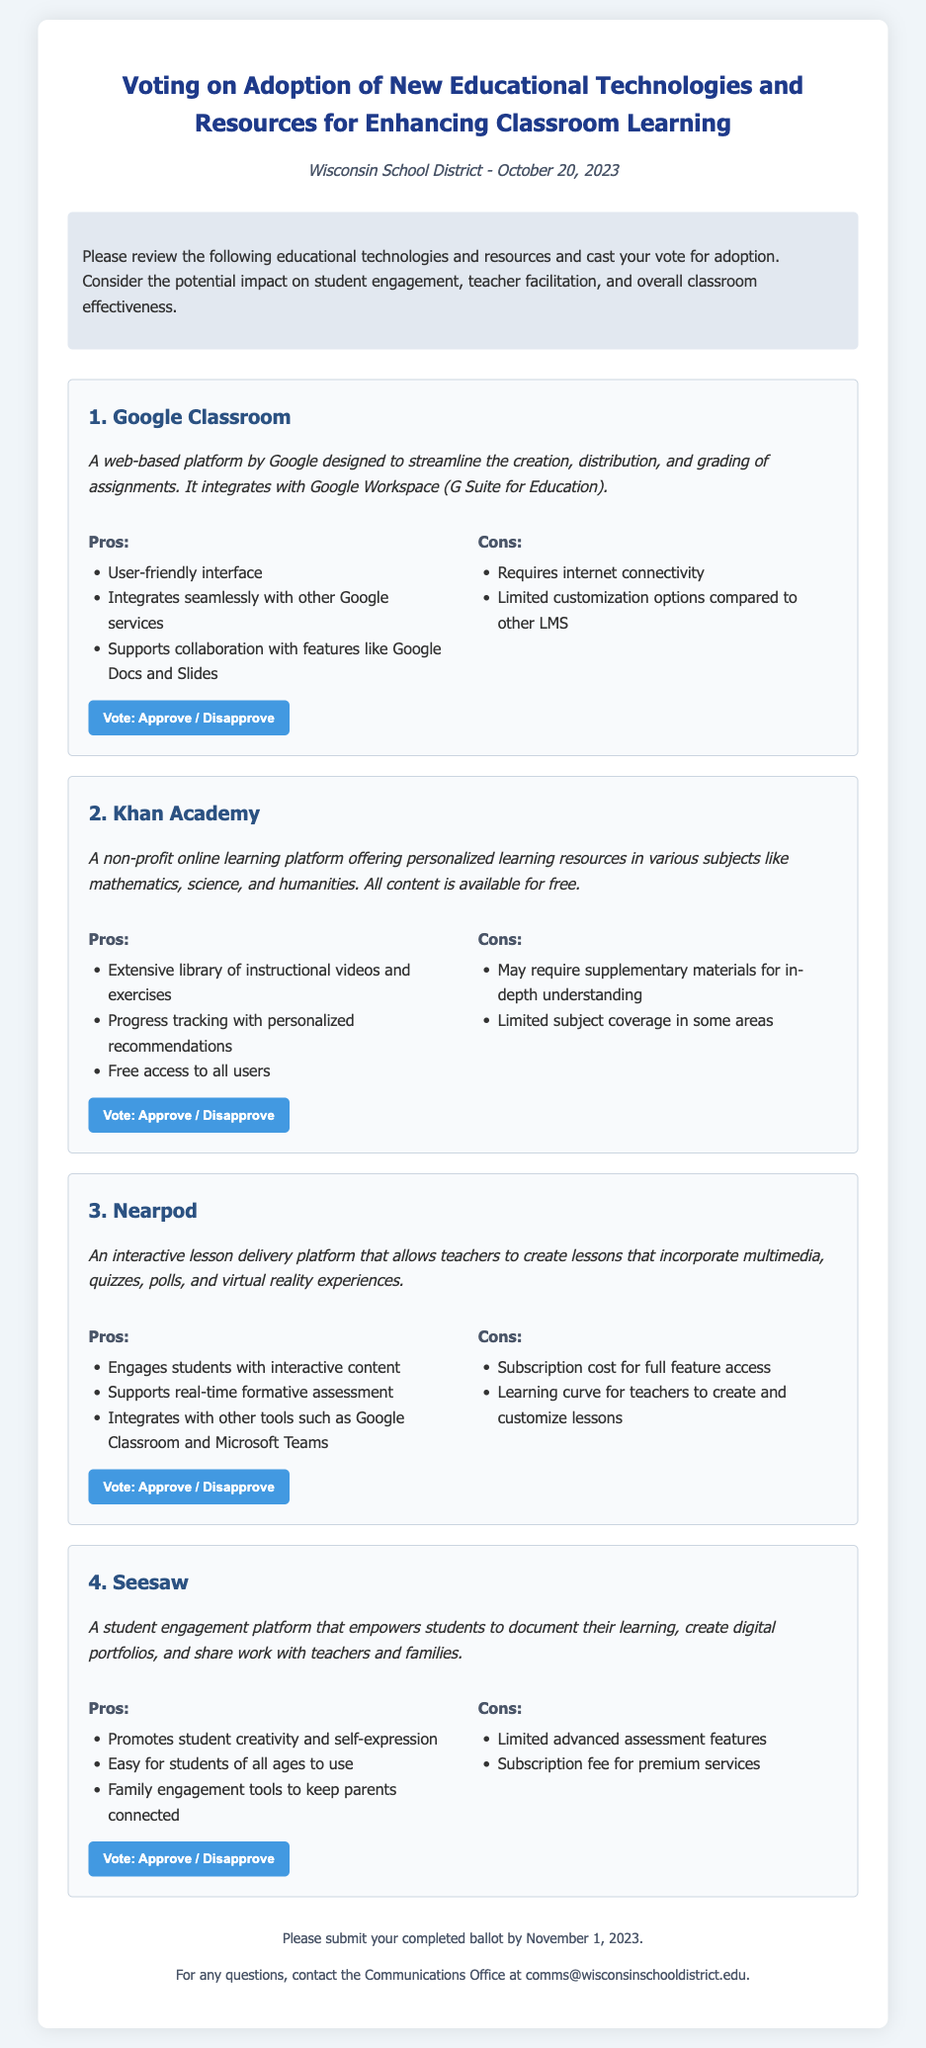What is the title of the document? The title of the document appears at the top of the page, indicating the purpose of the ballot.
Answer: Voting on Adoption of New Educational Technologies and Resources for Enhancing Classroom Learning When is the deadline to submit the ballot? The deadline is mentioned in the footer of the document, specifying when the completed ballot must be submitted.
Answer: November 1, 2023 How many educational technologies are listed in the ballot? The document features a total outlined list of educational technologies presented for voting.
Answer: 4 What is one of the cons for Google Classroom? The cons section lists negative aspects related to Google Classroom's usage, as specified in the document.
Answer: Requires internet connectivity Which educational technology provides free access to all users? Khan Academy is described as a platform with no charges for users, highlighted in its description.
Answer: Khan Academy What type of content does Nearpod allow teachers to create? The document explicitly discusses the type of lessons Nearpod enables educators to develop.
Answer: Interactive lessons What is a key benefit of using Seesaw according to the pros? The document lists benefits of Seesaw, emphasizing its advantages for students and families.
Answer: Promotes student creativity and self-expression What organization is associated with this voting document? The organization name that is responsible for the ballot is included in the document header.
Answer: Wisconsin School District 